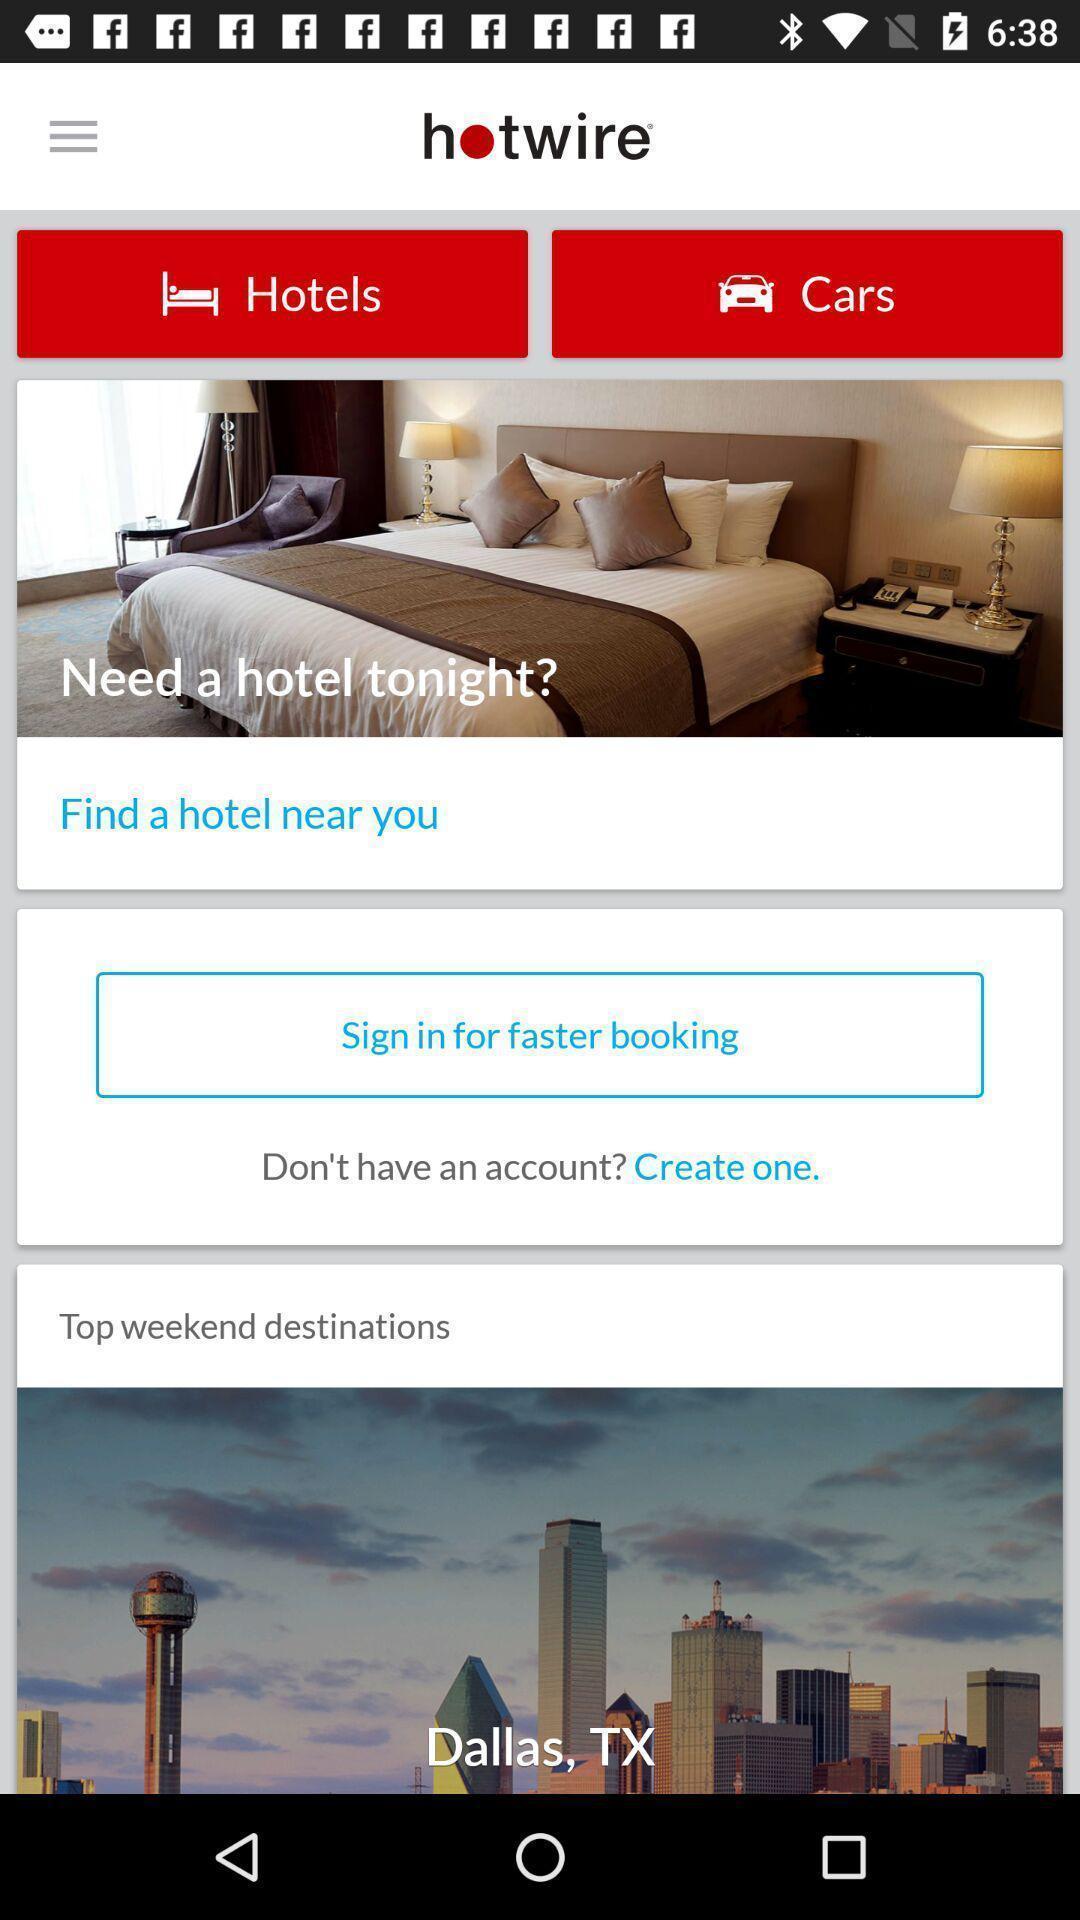Summarize the information in this screenshot. Sign in page of a booking app. 